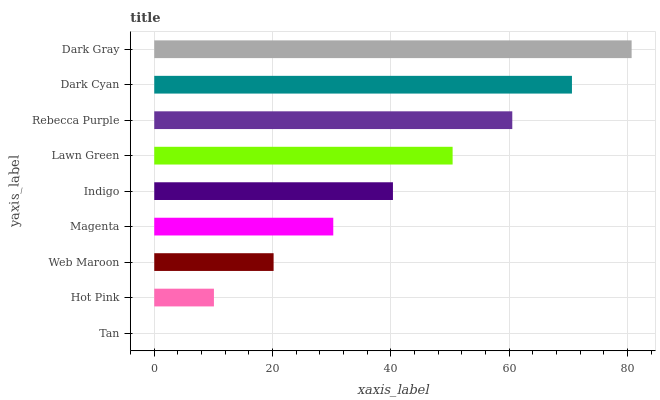Is Tan the minimum?
Answer yes or no. Yes. Is Dark Gray the maximum?
Answer yes or no. Yes. Is Hot Pink the minimum?
Answer yes or no. No. Is Hot Pink the maximum?
Answer yes or no. No. Is Hot Pink greater than Tan?
Answer yes or no. Yes. Is Tan less than Hot Pink?
Answer yes or no. Yes. Is Tan greater than Hot Pink?
Answer yes or no. No. Is Hot Pink less than Tan?
Answer yes or no. No. Is Indigo the high median?
Answer yes or no. Yes. Is Indigo the low median?
Answer yes or no. Yes. Is Dark Gray the high median?
Answer yes or no. No. Is Dark Cyan the low median?
Answer yes or no. No. 